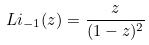Convert formula to latex. <formula><loc_0><loc_0><loc_500><loc_500>L i _ { - 1 } ( z ) = \frac { z } { ( 1 - z ) ^ { 2 } }</formula> 